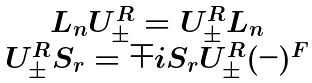Convert formula to latex. <formula><loc_0><loc_0><loc_500><loc_500>\begin{array} { c } L _ { n } U _ { \pm } ^ { R } = U _ { \pm } ^ { R } L _ { n } \\ U _ { \pm } ^ { R } S _ { r } = \mp i S _ { r } U _ { \pm } ^ { R } ( - ) ^ { F } \end{array}</formula> 